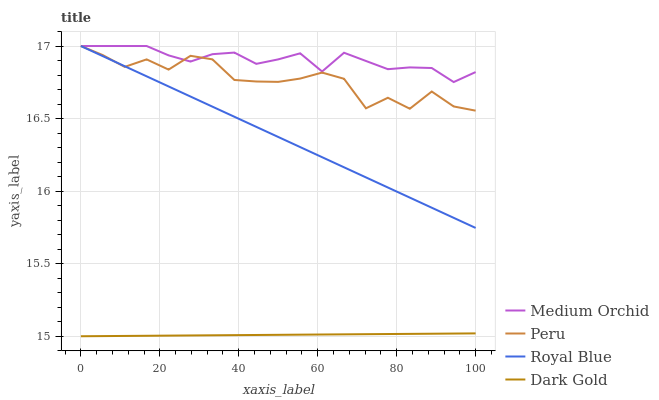Does Peru have the minimum area under the curve?
Answer yes or no. No. Does Peru have the maximum area under the curve?
Answer yes or no. No. Is Medium Orchid the smoothest?
Answer yes or no. No. Is Medium Orchid the roughest?
Answer yes or no. No. Does Peru have the lowest value?
Answer yes or no. No. Does Dark Gold have the highest value?
Answer yes or no. No. Is Dark Gold less than Royal Blue?
Answer yes or no. Yes. Is Peru greater than Dark Gold?
Answer yes or no. Yes. Does Dark Gold intersect Royal Blue?
Answer yes or no. No. 